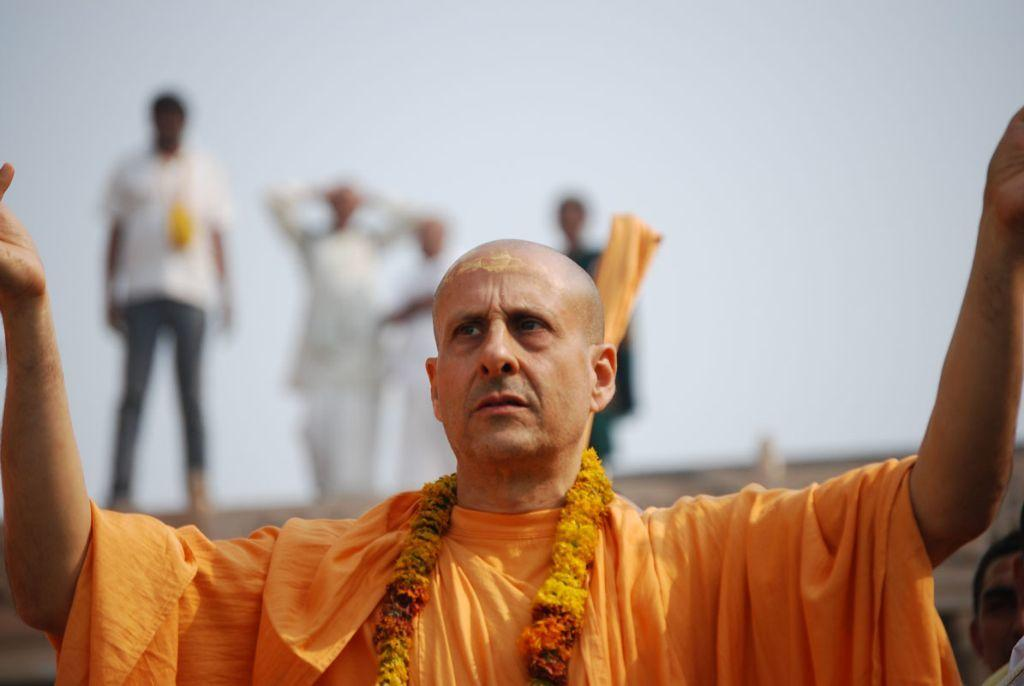Who is the main subject in the image? There is a man in the image. What is the man wearing? The man is wearing an orange dress. What is the man holding around his neck? The man has a garland. What is the man doing with his hands? The man is putting his hands up. How many people are standing behind the man? There are four people standing behind the man. What can be seen in the background of the image? The sky is visible in the background of the image. What scent can be detected from the man's dress in the image? There is no information about the scent of the man's dress in the image. What type of calculator is being used by the man in the image? There is no calculator present in the image. 